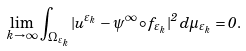<formula> <loc_0><loc_0><loc_500><loc_500>\lim _ { k \to \infty } \, \int _ { \Omega _ { \varepsilon _ { k } } } | u ^ { \varepsilon _ { k } } - \psi ^ { \infty } \circ f _ { \varepsilon _ { k } } | ^ { 2 } \, d \mu _ { \varepsilon _ { k } } = 0 .</formula> 